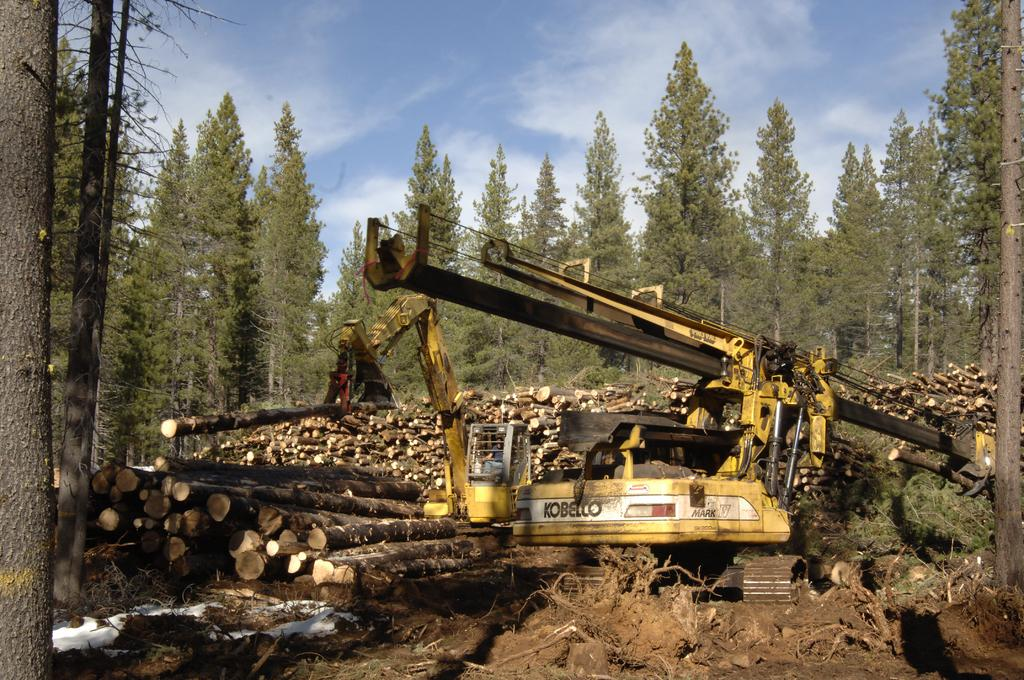<image>
Describe the image concisely. A large yellow Kobello piece of equipment helps to clear the trees. 